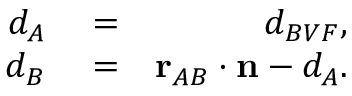Convert formula to latex. <formula><loc_0><loc_0><loc_500><loc_500>\begin{array} { r l r } { d _ { A } } & = } & { d _ { B V F } , } \\ { d _ { B } } & = } & { r _ { A B } \cdot n - d _ { A } . } \end{array}</formula> 